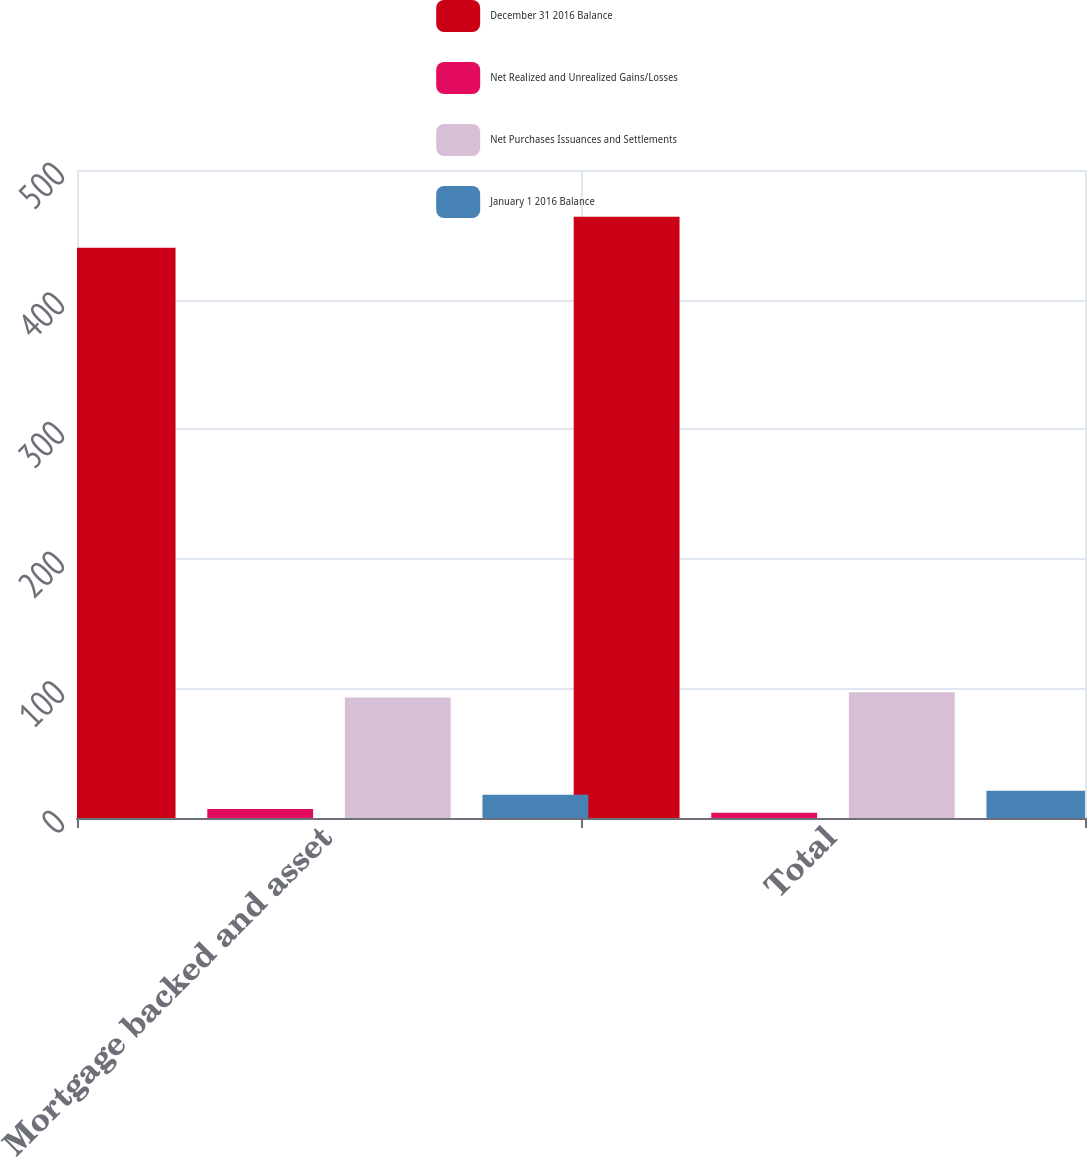<chart> <loc_0><loc_0><loc_500><loc_500><stacked_bar_chart><ecel><fcel>Mortgage backed and asset<fcel>Total<nl><fcel>December 31 2016 Balance<fcel>440<fcel>464<nl><fcel>Net Realized and Unrealized Gains/Losses<fcel>7<fcel>4<nl><fcel>Net Purchases Issuances and Settlements<fcel>93<fcel>97<nl><fcel>January 1 2016 Balance<fcel>18<fcel>21<nl></chart> 